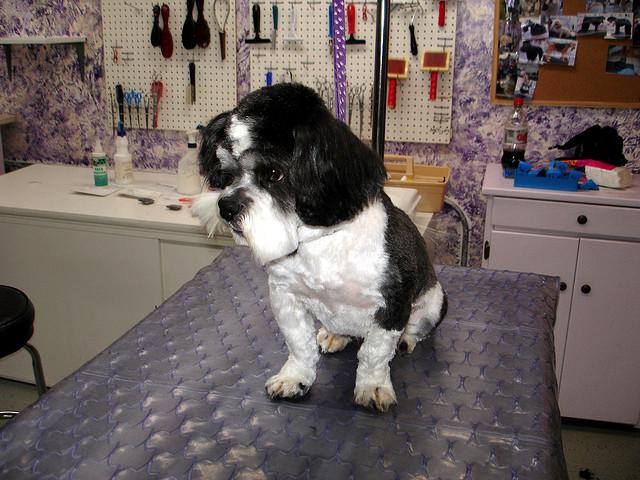What kind of office is this?
Answer briefly. Vet. Is the dog standing?
Give a very brief answer. No. Is the dog wearing glasses?
Short answer required. No. What is the dog doing?
Concise answer only. Sitting. 